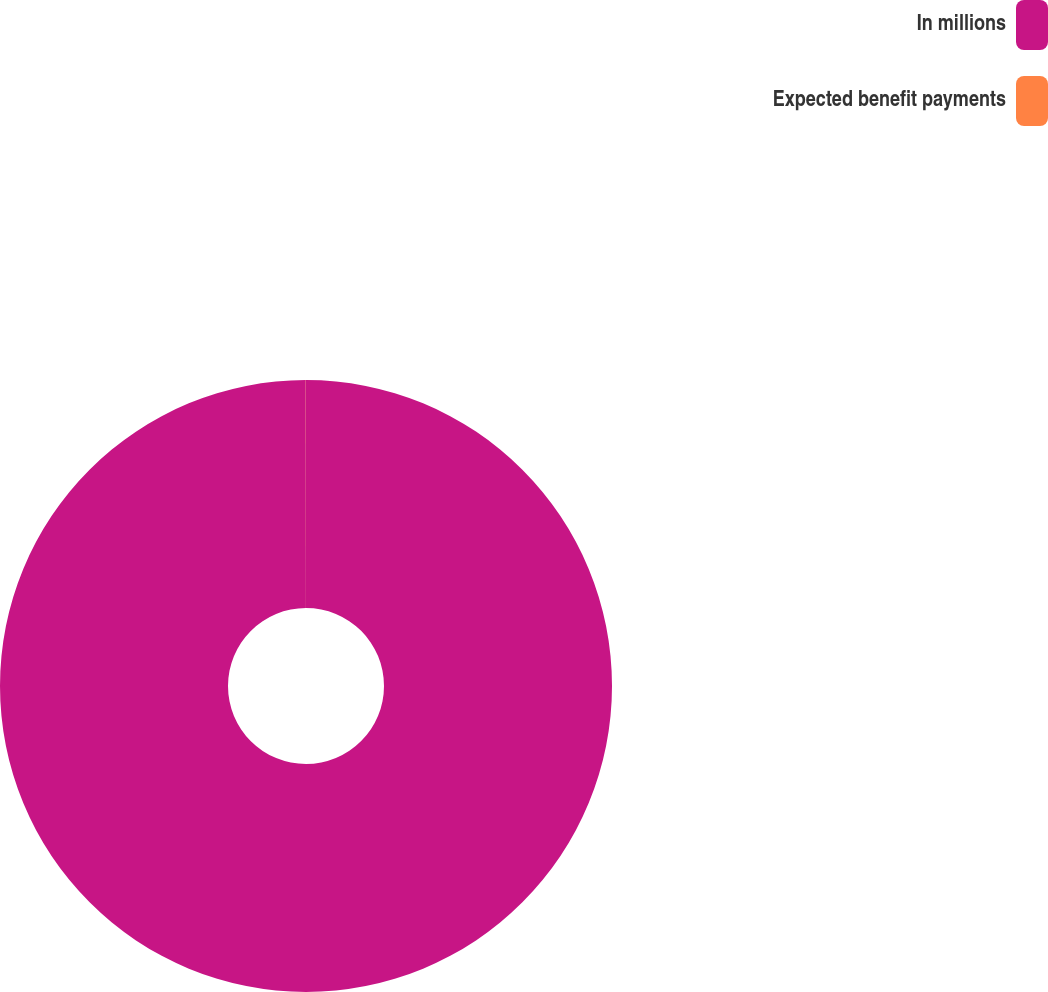Convert chart. <chart><loc_0><loc_0><loc_500><loc_500><pie_chart><fcel>In millions<fcel>Expected benefit payments<nl><fcel>99.99%<fcel>0.01%<nl></chart> 